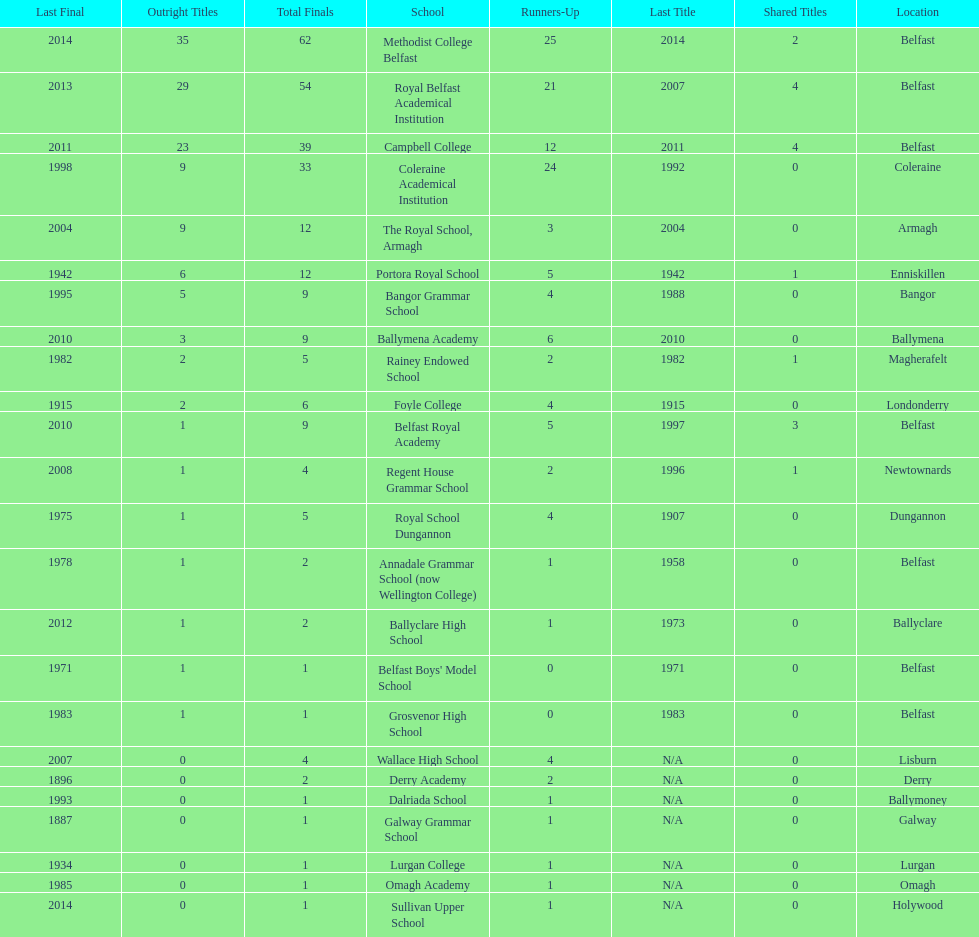How many schools have had at least 3 share titles? 3. 